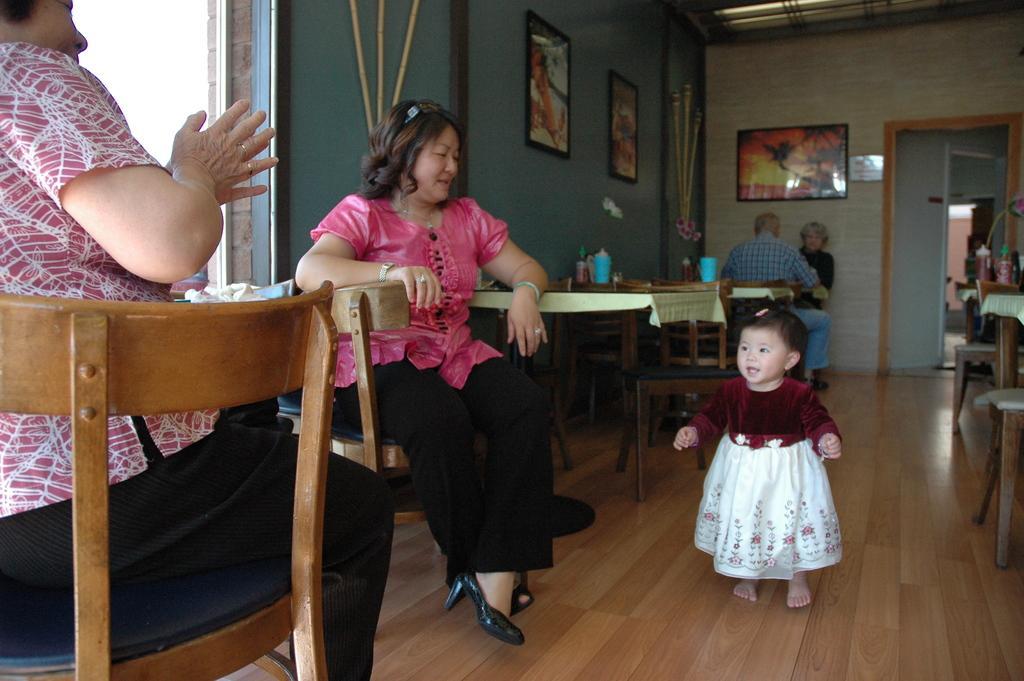Can you describe this image briefly? Here we can see two women sitting on chairs and there are tables present in the hall and there is a baby in the middle, there are portraits present on the wall 